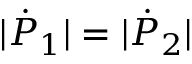Convert formula to latex. <formula><loc_0><loc_0><loc_500><loc_500>| { \dot { P } } _ { 1 } | = | { \dot { P } } _ { 2 } |</formula> 